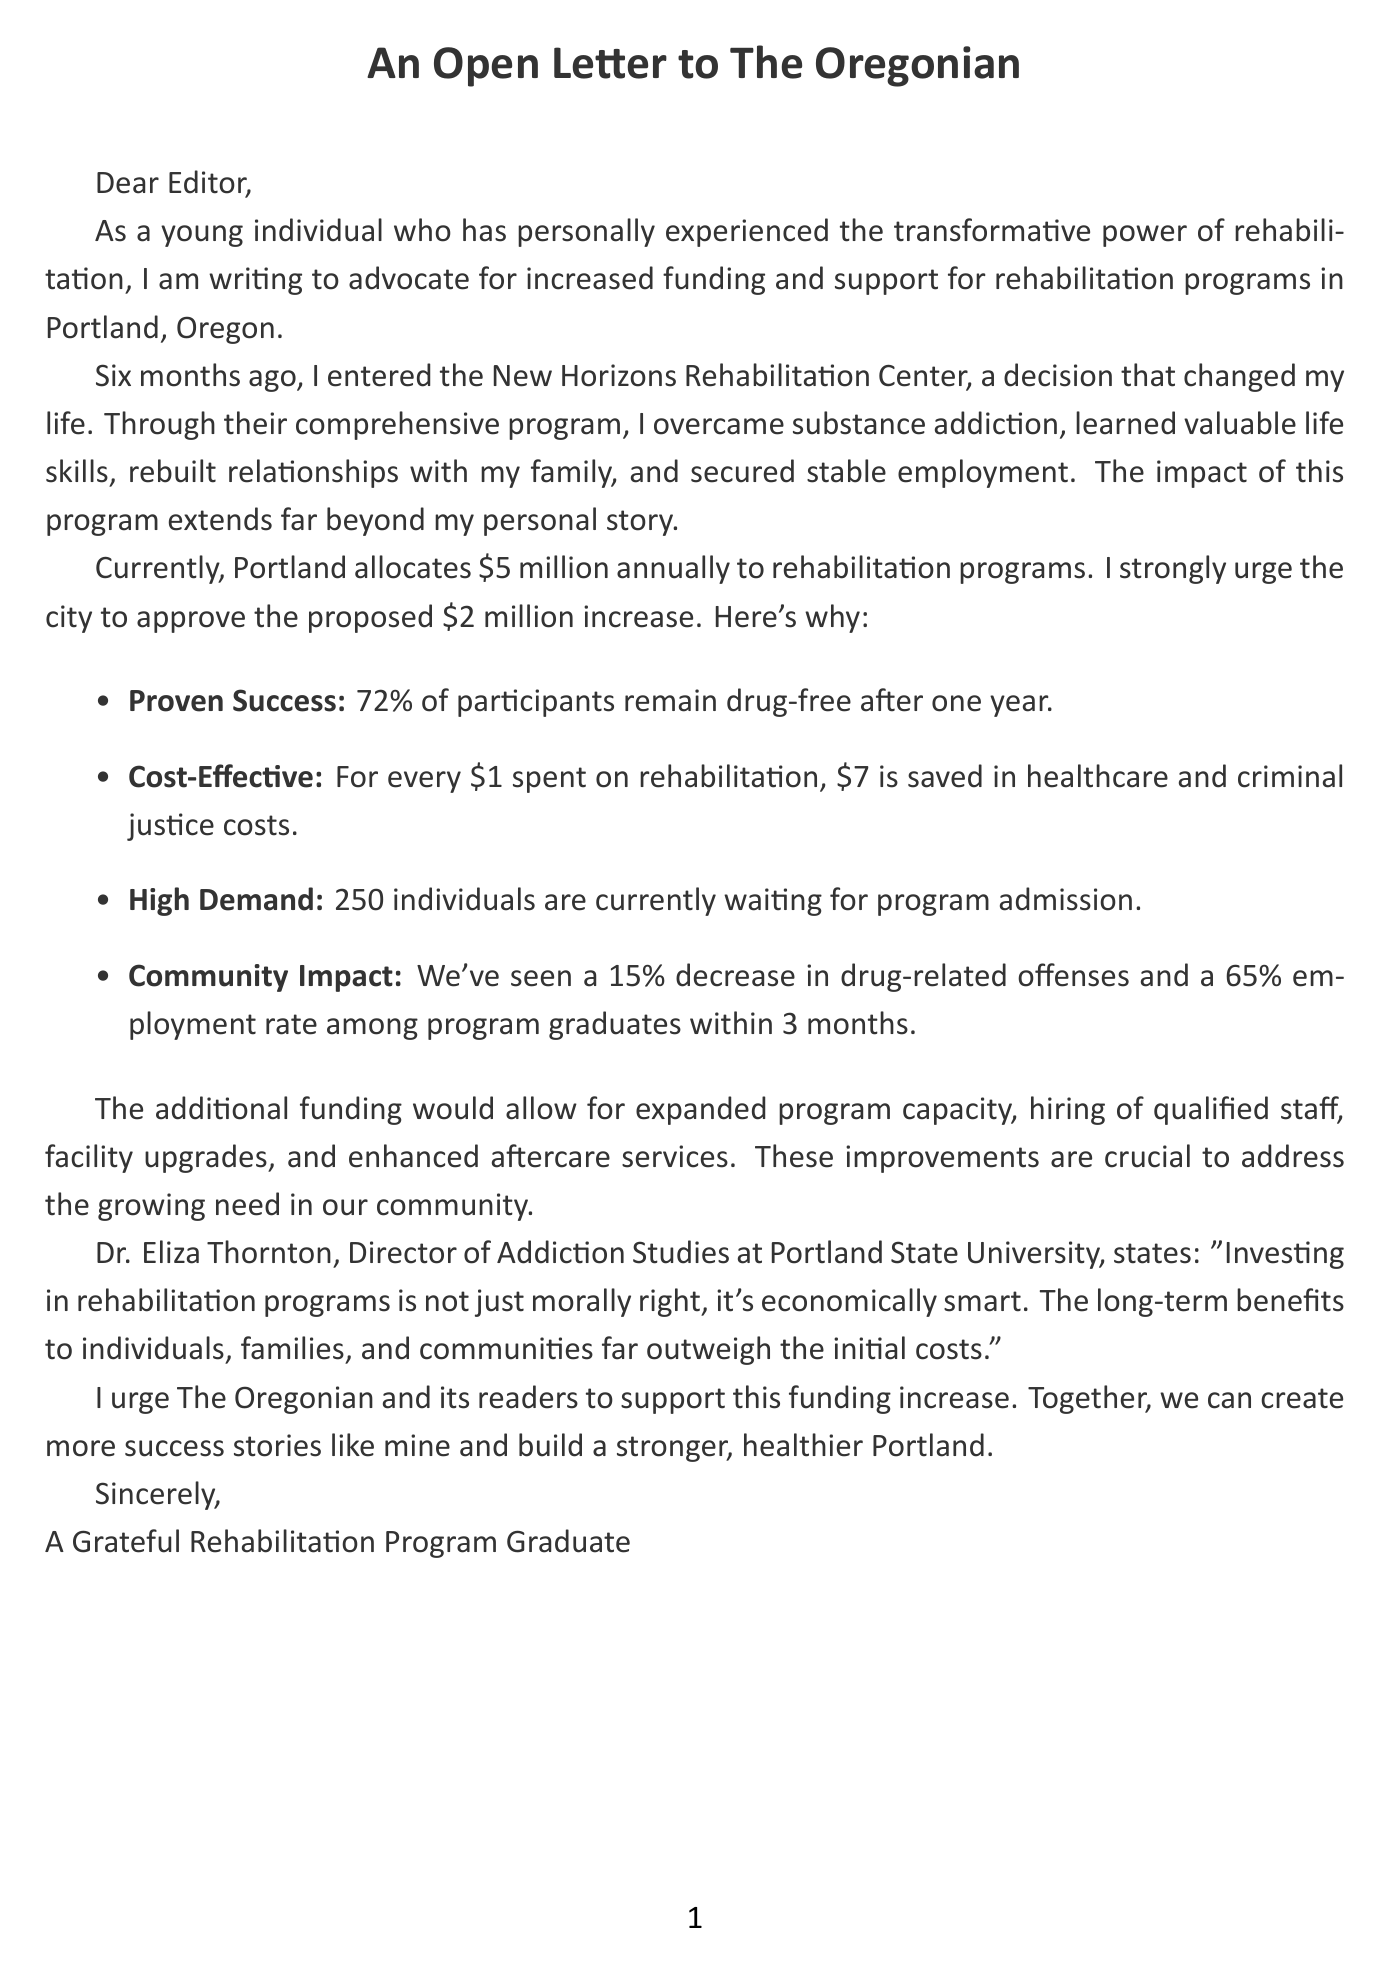What is the name of the rehabilitation program mentioned? The document identifies the program as the New Horizons Rehabilitation Center.
Answer: New Horizons Rehabilitation Center How long did the author participate in the program? The author states they participated in the program for six months.
Answer: 6 months What is the current funding allocated for rehabilitation programs in Portland? The document specifies that Portland currently allocates $5 million annually to rehabilitation programs.
Answer: $5 million What is the proposed increase in funding? The letter requests an additional funding increase of $2 million.
Answer: $2 million What percentage of program graduates are employed within 3 months? The document mentions that 65% of program graduates gainfully employed within 3 months.
Answer: 65% What is the success rate of participants remaining drug-free after one year? The document states that 72% of participants remain drug-free after one year.
Answer: 72% How many individuals are currently on the waiting list for program admission? The letter notes that there are 250 individuals currently waiting for program admission.
Answer: 250 Who is quoted in the letter regarding the economic benefits of rehabilitation programs? Dr. Eliza Thornton, the Director of Addiction Studies at Portland State University, is quoted in the letter.
Answer: Dr. Eliza Thornton What is one of the proposed uses for the increased funding? The letter suggests that expanded program capacity is one of the proposed uses for the increased funding.
Answer: Expand program capacity 